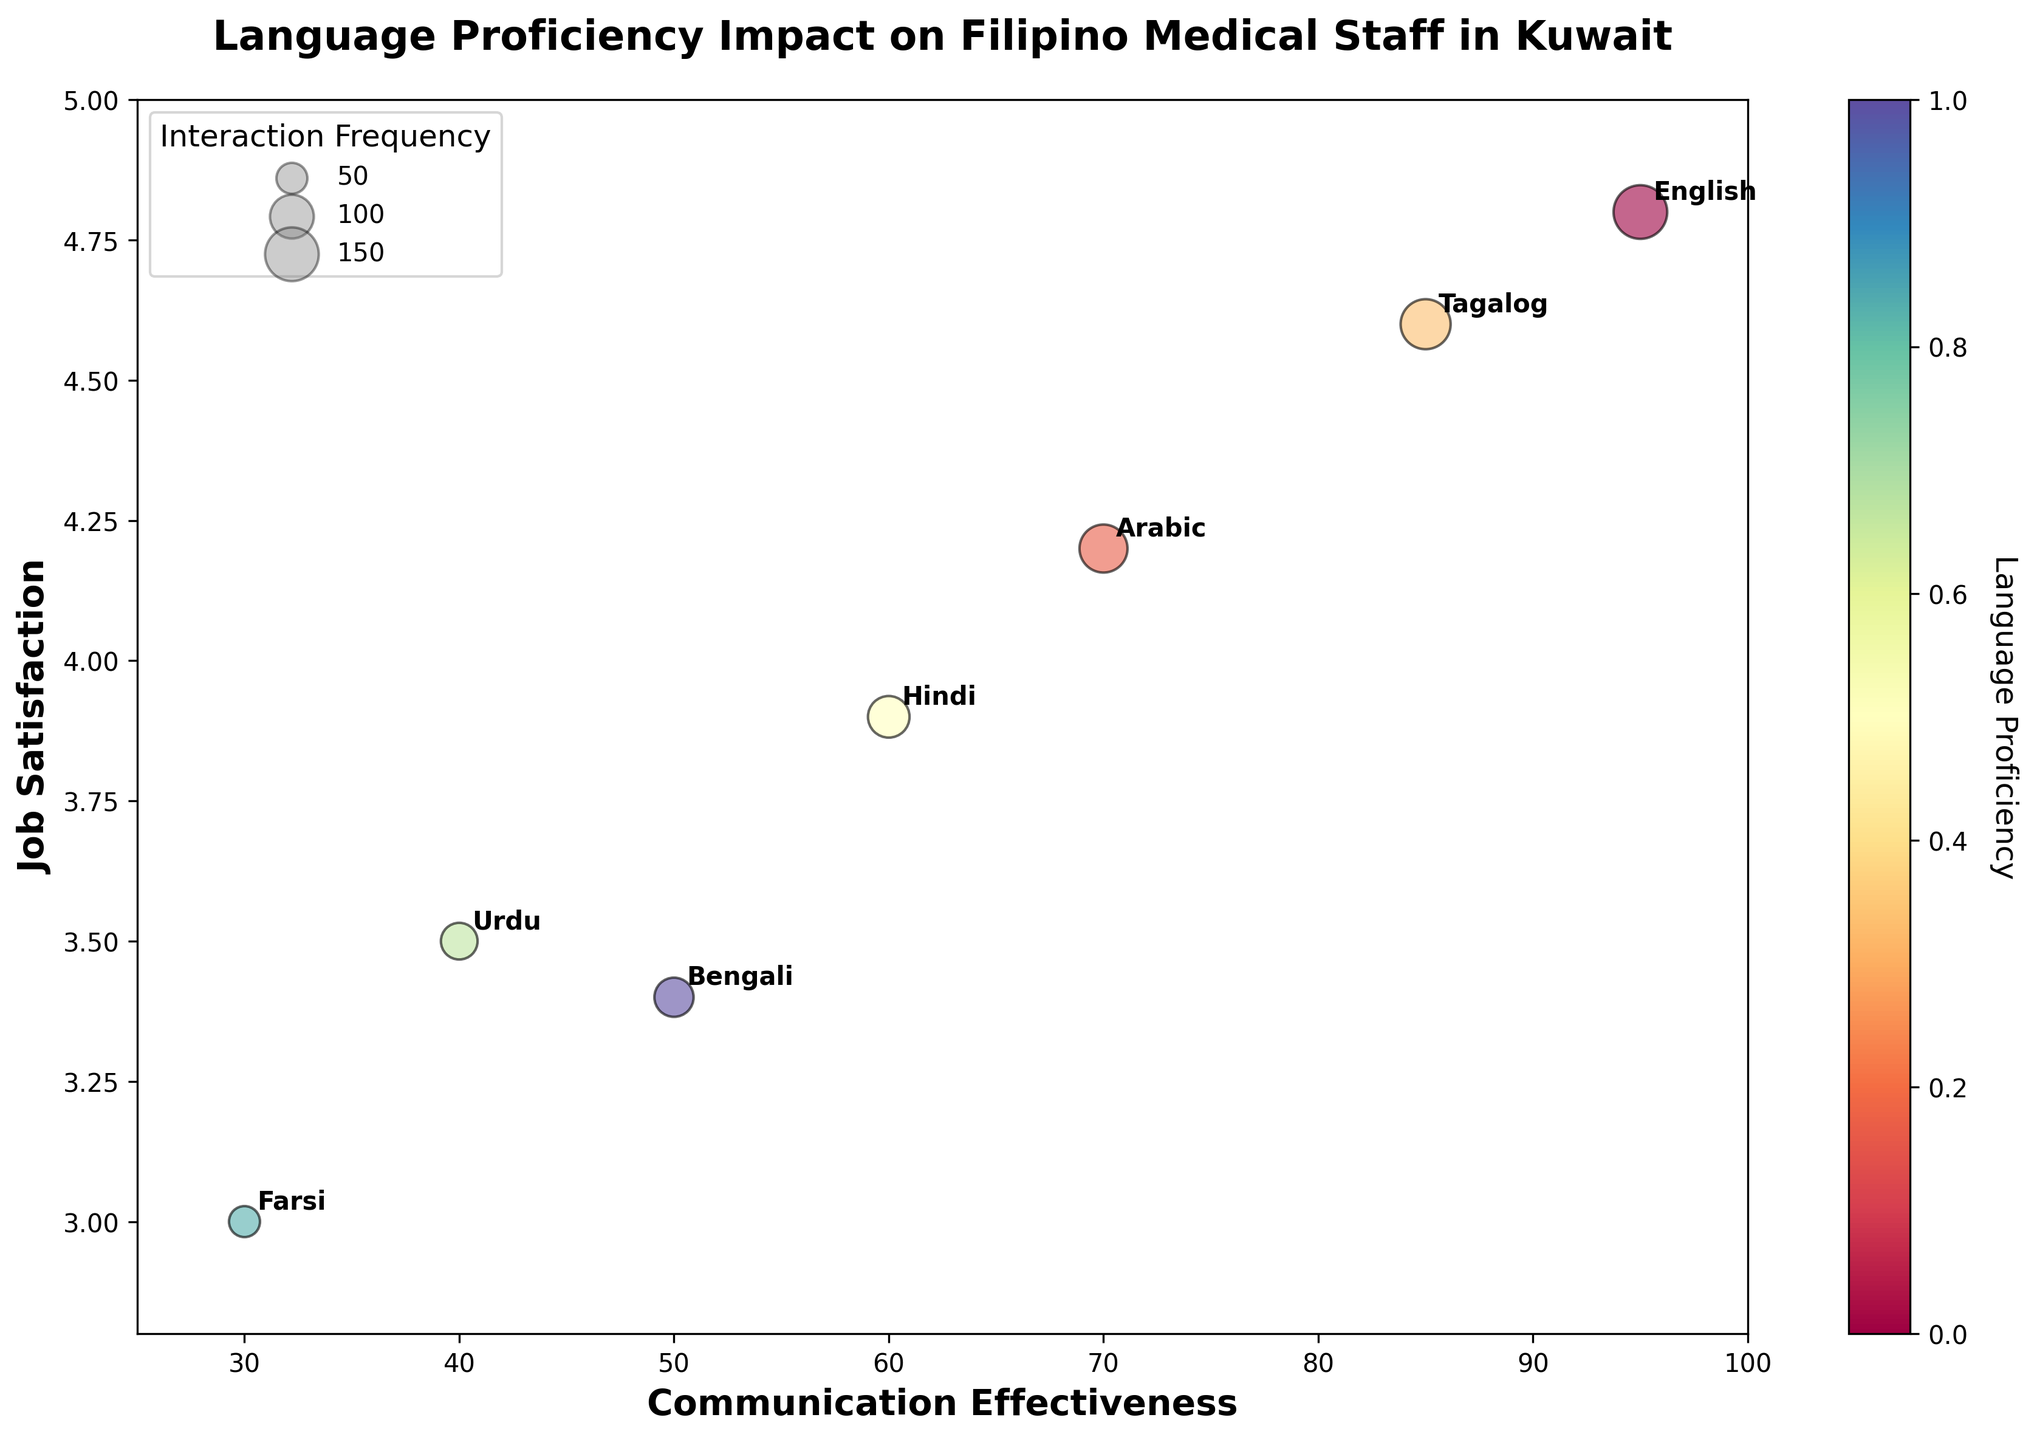what's the title of the chart? The title of the chart is displayed at the top, centrally aligned, in bold letters. It's visible without needing to interpret the data.
Answer: Language Proficiency Impact on Filipino Medical Staff in Kuwait How many languages are represented in the bubble chart? By counting the distinct bubbles, each labeled with a language, you can determine the number of languages. This visual inspection reveals there are seven.
Answer: 7 Which language has the highest communication effectiveness? Looking for the bubble highest on the x-axis (Communication Effectiveness) reveals that English is the farthest to the right, indicating the highest value.
Answer: English Which language shows the lowest job satisfaction? The bubble situated lowest on the y-axis (Job Satisfaction), representing the lowest value, is Farsi.
Answer: Farsi What is the interaction frequency for Tagalog? Identify the bubble labeled "Tagalog" and note the size of the bubble. According to the bubble size legend, Tagalog has an interaction frequency of 130.
Answer: 130 How many languages have a job satisfaction rating above 4.0? Locate bubbles above the 4.0 mark on the y-axis. English, Tagalog, and Arabic are above this threshold, summing to three languages.
Answer: 3 What's the difference in communication effectiveness between English and Arabic? Find the communication effectiveness values for English (95) and Arabic (70) and subtract the two values: 95 - 70 = 25.
Answer: 25 Which language has both communication effectiveness and job satisfaction below 50 and 4.0 respectively? Focusing on the lower regions of both axes reveals that Urdu meets these criteria with 40 for effectiveness and 3.5 for satisfaction.
Answer: Urdu Compare Tagalog to Hindi in terms of job satisfaction and interaction frequency. Compare the y-positions of Tagalog and Hindi for job satisfaction (4.6 vs 3.9) and bubble sizes for interaction frequency (130 vs 90). Tagalog has higher job satisfaction and interaction frequency.
Answer: Tagalog has higher Which language has the smallest bubble, and what does it indicate about interaction frequency? The smallest bubble on the plot, identified visually, is Farsi. According to the legend, this smallest bubble size corresponds to an interaction frequency of 50.
Answer: Farsi, 50 